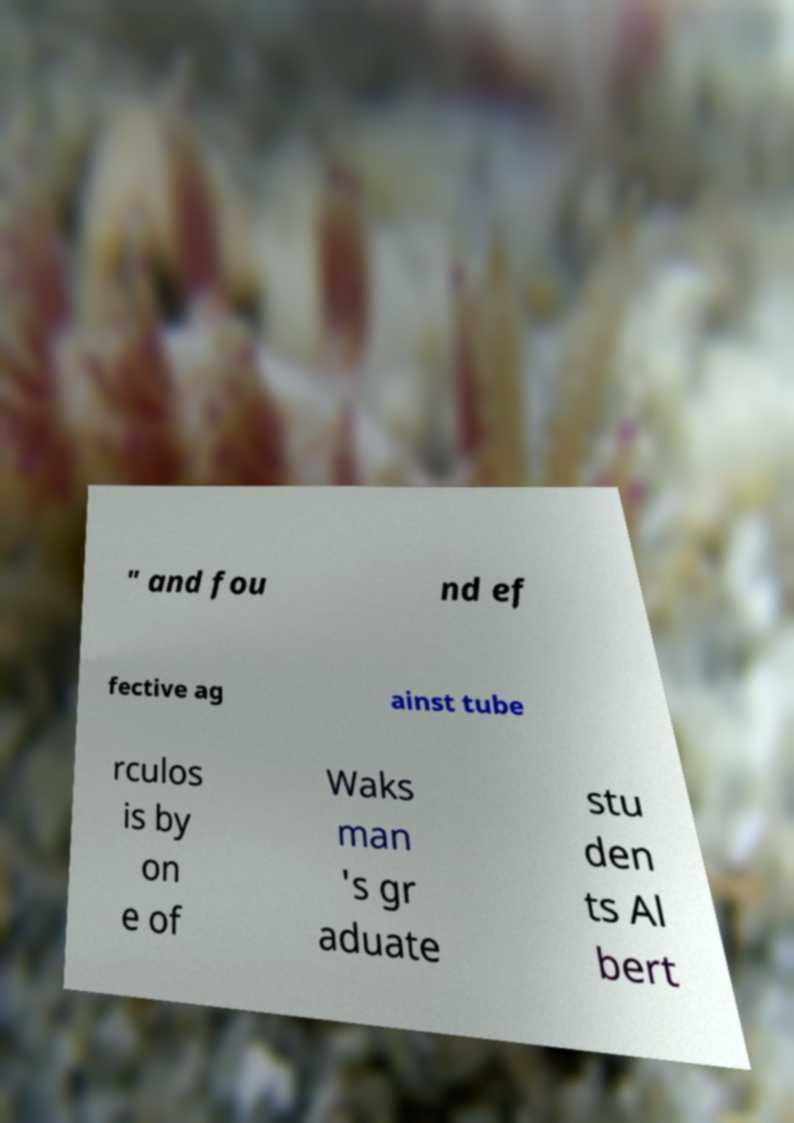What messages or text are displayed in this image? I need them in a readable, typed format. " and fou nd ef fective ag ainst tube rculos is by on e of Waks man 's gr aduate stu den ts Al bert 